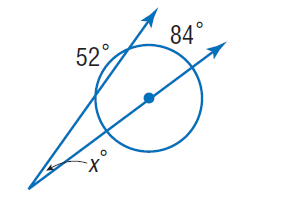Answer the mathemtical geometry problem and directly provide the correct option letter.
Question: Find x.
Choices: A: 20 B: 42 C: 52 D: 84 A 